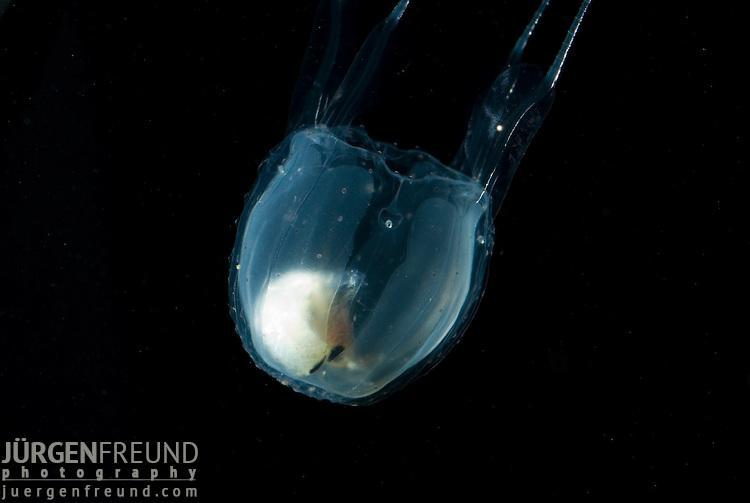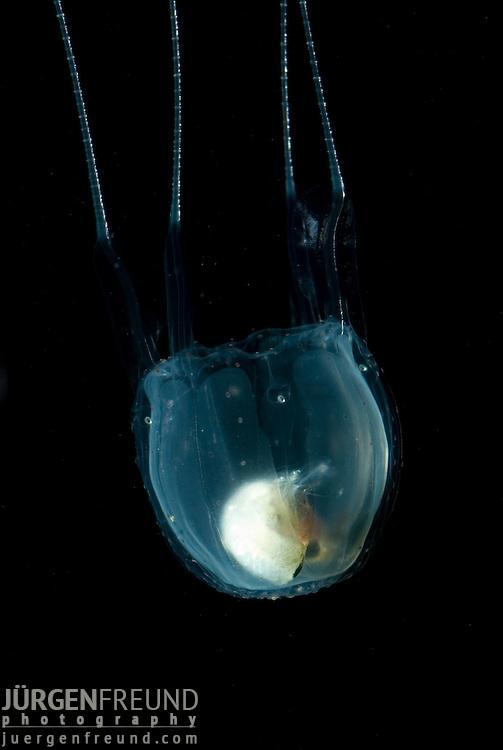The first image is the image on the left, the second image is the image on the right. Examine the images to the left and right. Is the description "Both jellyfish are upside down." accurate? Answer yes or no. Yes. The first image is the image on the left, the second image is the image on the right. Examine the images to the left and right. Is the description "Two clear jellyfish are swimming downwards." accurate? Answer yes or no. Yes. 